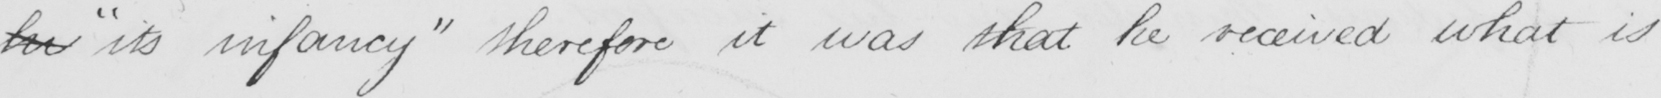Please transcribe the handwritten text in this image. hi  " its infancy "  therefore it was that he received what is 